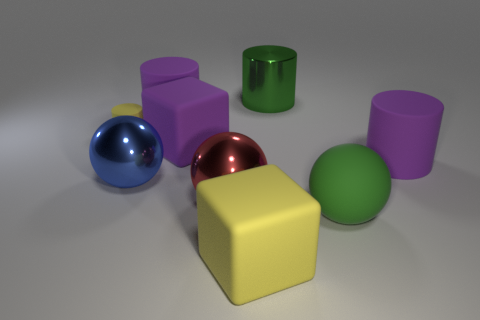Subtract all matte spheres. How many spheres are left? 2 Subtract all yellow balls. How many purple cylinders are left? 2 Add 1 large yellow objects. How many objects exist? 10 Subtract all green cylinders. How many cylinders are left? 3 Subtract 2 cylinders. How many cylinders are left? 2 Subtract all cubes. How many objects are left? 7 Subtract all gray cubes. Subtract all tiny things. How many objects are left? 8 Add 2 big green spheres. How many big green spheres are left? 3 Add 1 small rubber things. How many small rubber things exist? 2 Subtract 1 purple cylinders. How many objects are left? 8 